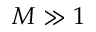<formula> <loc_0><loc_0><loc_500><loc_500>M \gg 1</formula> 